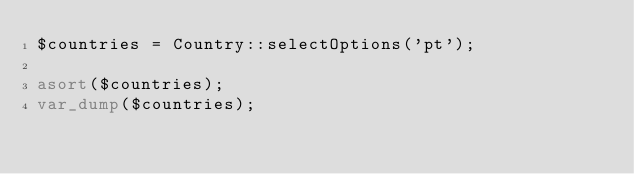Convert code to text. <code><loc_0><loc_0><loc_500><loc_500><_PHP_>$countries = Country::selectOptions('pt');

asort($countries);
var_dump($countries);
</code> 